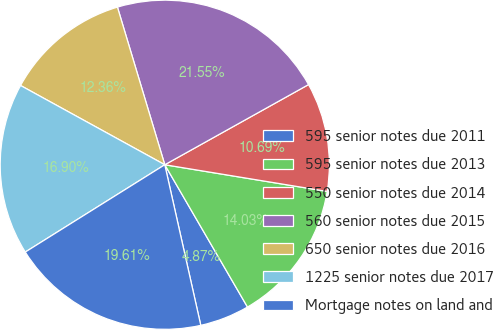Convert chart to OTSL. <chart><loc_0><loc_0><loc_500><loc_500><pie_chart><fcel>595 senior notes due 2011<fcel>595 senior notes due 2013<fcel>550 senior notes due 2014<fcel>560 senior notes due 2015<fcel>650 senior notes due 2016<fcel>1225 senior notes due 2017<fcel>Mortgage notes on land and<nl><fcel>4.87%<fcel>14.03%<fcel>10.69%<fcel>21.55%<fcel>12.36%<fcel>16.9%<fcel>19.61%<nl></chart> 